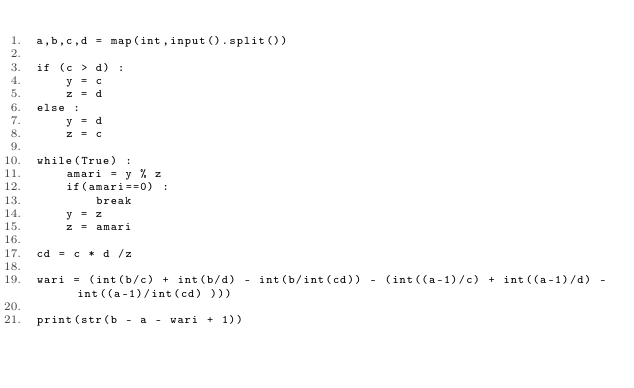Convert code to text. <code><loc_0><loc_0><loc_500><loc_500><_Python_>a,b,c,d = map(int,input().split())

if (c > d) :
    y = c
    z = d
else :
    y = d
    z = c

while(True) :
    amari = y % z
    if(amari==0) :
        break
    y = z
    z = amari

cd = c * d /z

wari = (int(b/c) + int(b/d) - int(b/int(cd)) - (int((a-1)/c) + int((a-1)/d) - int((a-1)/int(cd) )))

print(str(b - a - wari + 1))</code> 